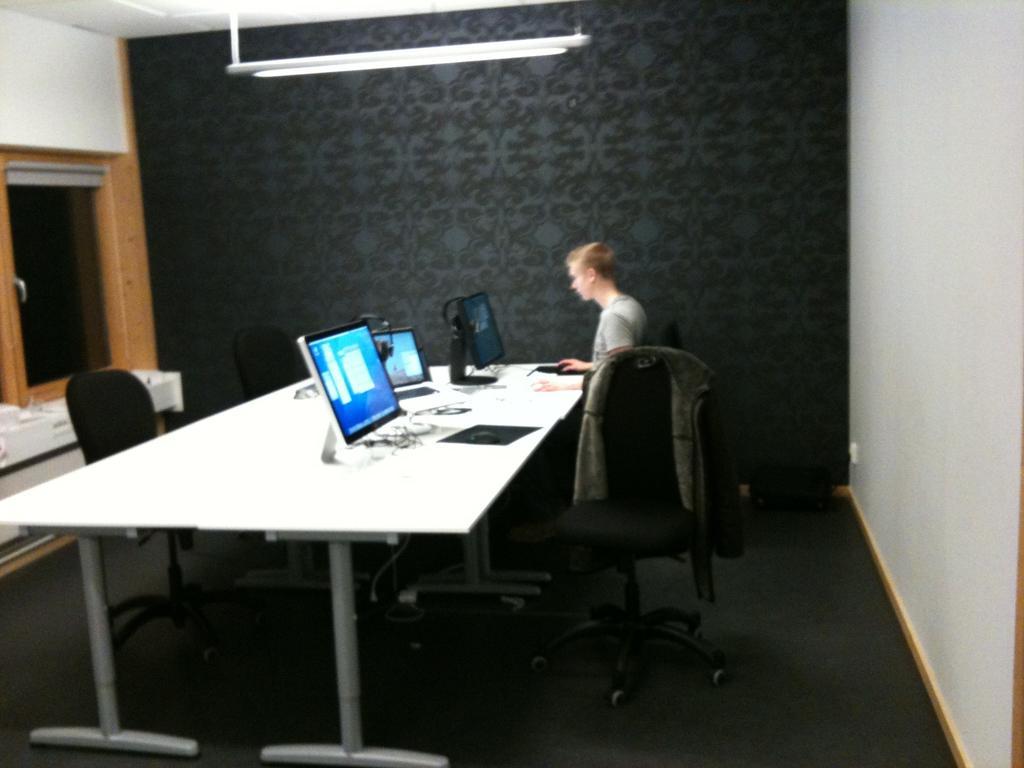Please provide a concise description of this image. In this image we can see this person is sitting on the chair and here we can see monitors, laptop, mouse, touchpad and wires are kept on the table. Here we can see a few more chairs, black color wall and the glass windows in the background. 